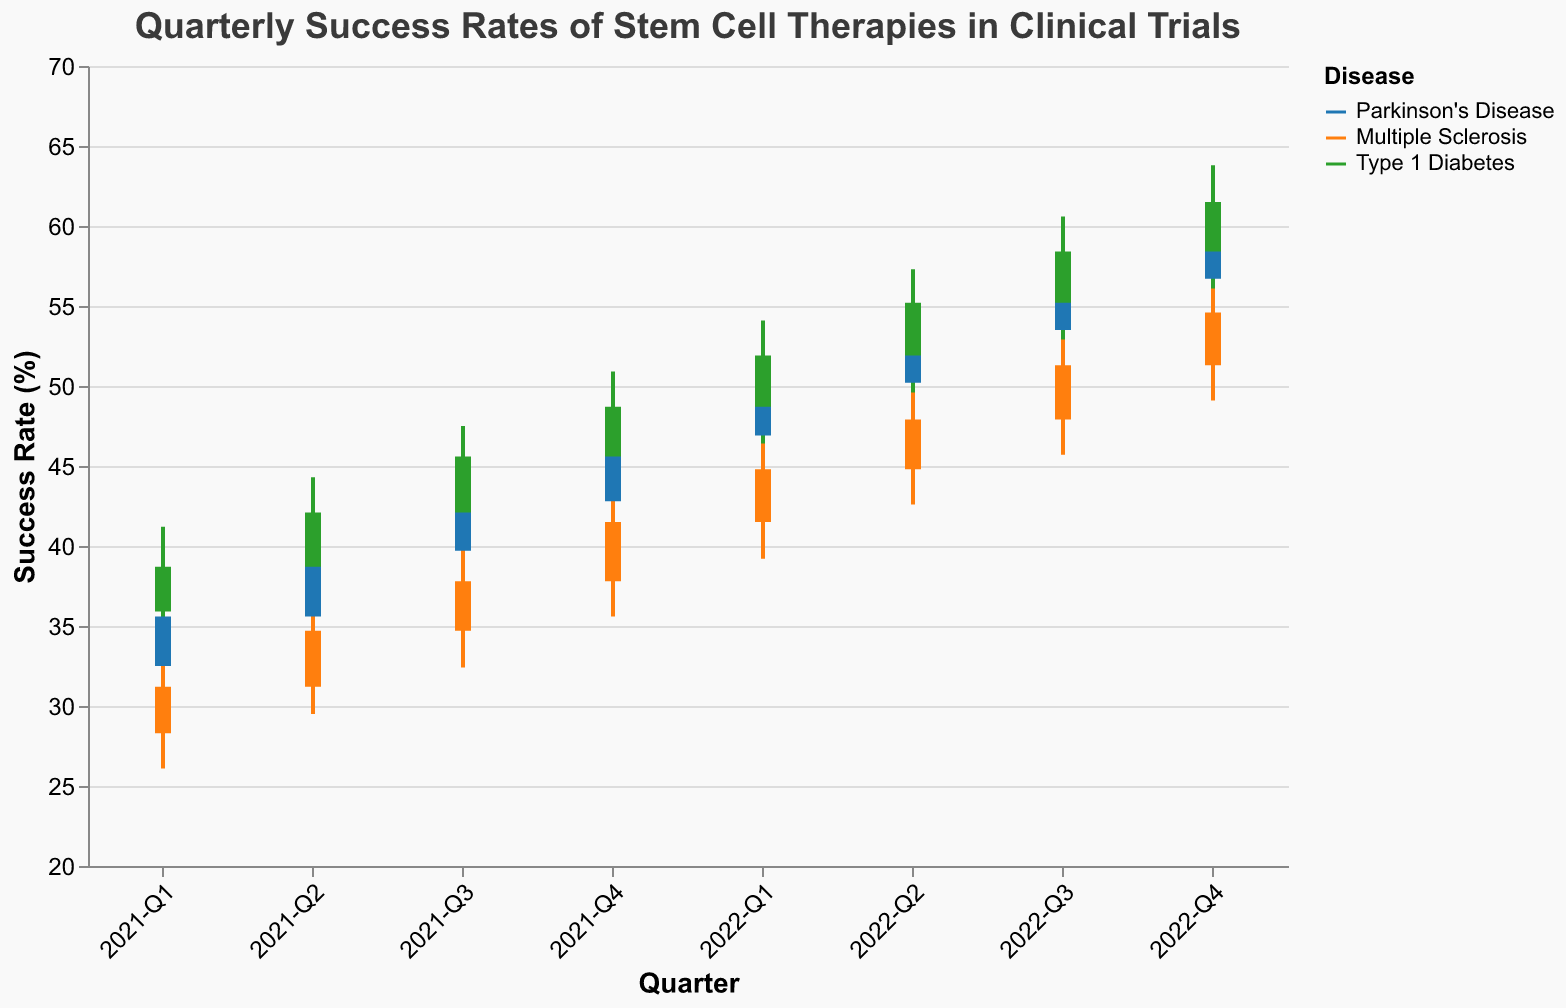What is the overall trend of success rates for Parkinson's Disease from 2021-Q1 to 2022-Q4? By examining the sequence of Close values for Parkinson's Disease, we can observe an upward trend from 35.6 in 2021-Q1 to 59.1 in 2022-Q4.
Answer: Upward trend What color represents Multiple Sclerosis in the figure? The legend indicates that Multiple Sclerosis is represented by the orange color.
Answer: Orange During which quarter did Type 1 Diabetes achieve its highest success rate? The OHLC chart shows the highest Close value for Type 1 Diabetes in 2022-Q4, which is 61.5.
Answer: 2022-Q4 Which disease had the highest success rate in 2021-Q4? Comparing the Close values for all diseases in 2021-Q4, Type 1 Diabetes had the highest success rate at 48.7.
Answer: Type 1 Diabetes How much did the success rate for Multiple Sclerosis increase from 2021-Q1 to 2022-Q4? The Close values for Multiple Sclerosis show an increase from 31.2 in 2021-Q1 to 54.6 in 2022-Q4, resulting in an increase of 54.6 - 31.2 = 23.4.
Answer: 23.4 Which quarter had the largest range of success rates for Parkinson's Disease, and what was the range? The largest range is found by subtracting the Low value from the High value in each quarter. For Parkinson's Disease, the largest range is in 2021-Q1 with a High of 38.2 and a Low of 29.8, resulting in a range of 38.2 - 29.8 = 8.4.
Answer: 2021-Q1, 8.4 What is the average closing success rate for Type 1 Diabetes in 2022? The Close values for Type 1 Diabetes in 2022 are 51.9, 55.2, 58.4, and 61.5. The average is calculated as (51.9 + 55.2 + 58.4 + 61.5) / 4 = 56.75.
Answer: 56.75 How did the success rate for Parkinson's Disease change from 2021-Q2 to 2021-Q3? The Close values for Parkinson's Disease show an increase from 39.7 in 2021-Q2 to 42.8 in 2021-Q3, which is an increase of 42.8 - 39.7 = 3.1.
Answer: Increased by 3.1 Across all diseases, which quarter had the most stable success rates, and how is this determined? Stability can be determined by the smallest range (difference between High and Low). By looking at the ranges for each quarter, 2021-Q3 has relatively small ranges for all diseases, indicating stability.
Answer: 2021-Q3 